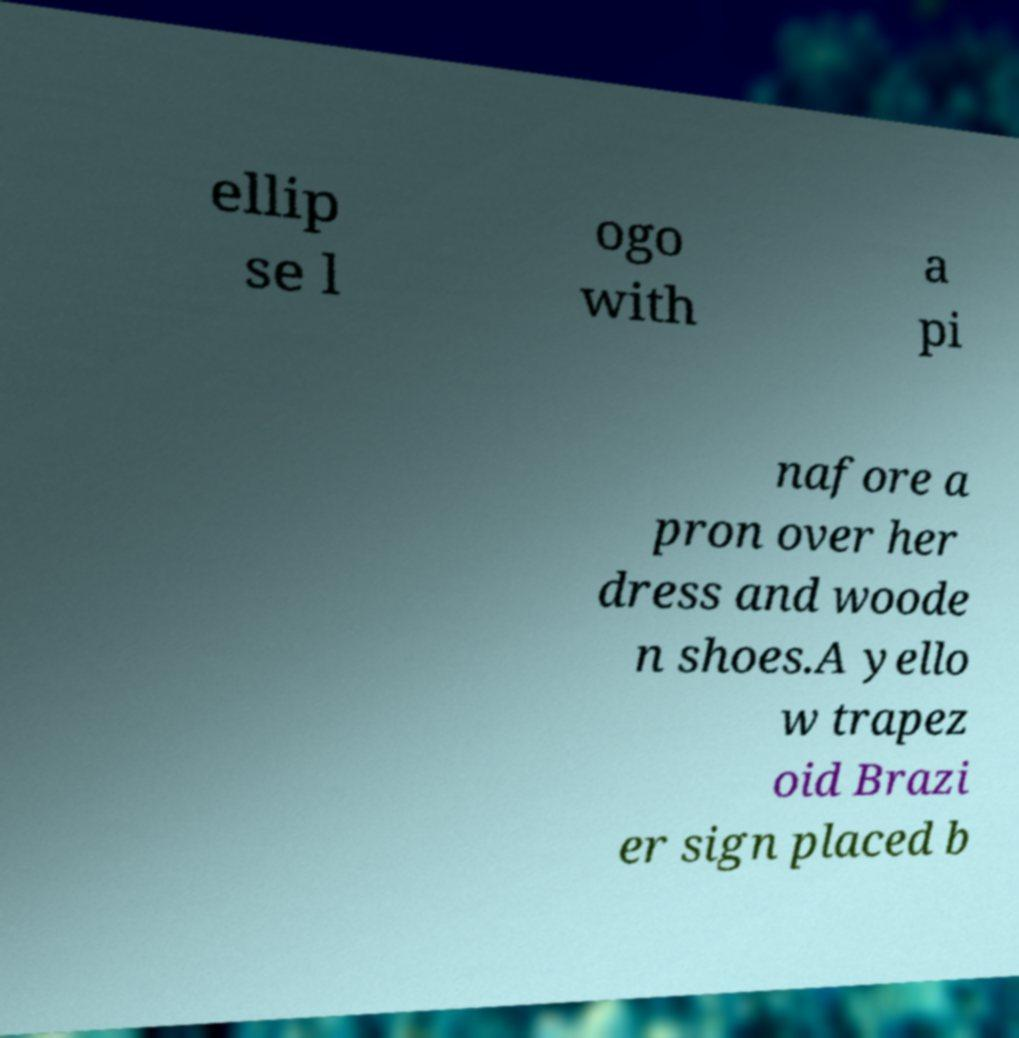Can you read and provide the text displayed in the image?This photo seems to have some interesting text. Can you extract and type it out for me? ellip se l ogo with a pi nafore a pron over her dress and woode n shoes.A yello w trapez oid Brazi er sign placed b 